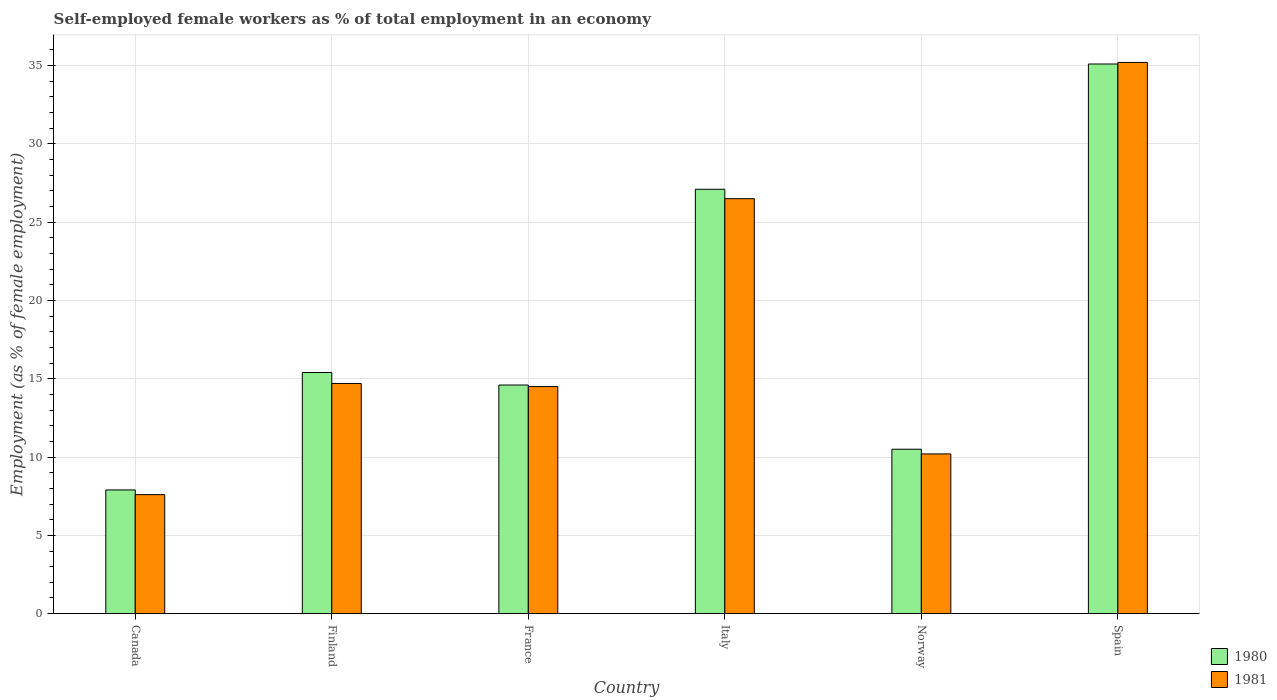How many different coloured bars are there?
Offer a terse response. 2. How many groups of bars are there?
Provide a short and direct response. 6. Are the number of bars per tick equal to the number of legend labels?
Keep it short and to the point. Yes. How many bars are there on the 5th tick from the left?
Make the answer very short. 2. What is the percentage of self-employed female workers in 1980 in Italy?
Provide a short and direct response. 27.1. Across all countries, what is the maximum percentage of self-employed female workers in 1980?
Your answer should be very brief. 35.1. Across all countries, what is the minimum percentage of self-employed female workers in 1980?
Your answer should be compact. 7.9. What is the total percentage of self-employed female workers in 1980 in the graph?
Offer a terse response. 110.6. What is the difference between the percentage of self-employed female workers in 1980 in Canada and that in Spain?
Make the answer very short. -27.2. What is the difference between the percentage of self-employed female workers in 1980 in Finland and the percentage of self-employed female workers in 1981 in Italy?
Your response must be concise. -11.1. What is the average percentage of self-employed female workers in 1981 per country?
Provide a short and direct response. 18.12. What is the difference between the percentage of self-employed female workers of/in 1981 and percentage of self-employed female workers of/in 1980 in Canada?
Keep it short and to the point. -0.3. What is the ratio of the percentage of self-employed female workers in 1981 in Finland to that in Italy?
Ensure brevity in your answer.  0.55. Is the percentage of self-employed female workers in 1980 in Finland less than that in Spain?
Give a very brief answer. Yes. What is the difference between the highest and the second highest percentage of self-employed female workers in 1981?
Provide a short and direct response. -8.7. What is the difference between the highest and the lowest percentage of self-employed female workers in 1981?
Keep it short and to the point. 27.6. In how many countries, is the percentage of self-employed female workers in 1981 greater than the average percentage of self-employed female workers in 1981 taken over all countries?
Make the answer very short. 2. What does the 2nd bar from the left in Spain represents?
Give a very brief answer. 1981. How many bars are there?
Ensure brevity in your answer.  12. Are all the bars in the graph horizontal?
Provide a succinct answer. No. What is the difference between two consecutive major ticks on the Y-axis?
Give a very brief answer. 5. Are the values on the major ticks of Y-axis written in scientific E-notation?
Give a very brief answer. No. Does the graph contain any zero values?
Give a very brief answer. No. How are the legend labels stacked?
Provide a succinct answer. Vertical. What is the title of the graph?
Your response must be concise. Self-employed female workers as % of total employment in an economy. What is the label or title of the Y-axis?
Make the answer very short. Employment (as % of female employment). What is the Employment (as % of female employment) in 1980 in Canada?
Make the answer very short. 7.9. What is the Employment (as % of female employment) of 1981 in Canada?
Make the answer very short. 7.6. What is the Employment (as % of female employment) in 1980 in Finland?
Provide a succinct answer. 15.4. What is the Employment (as % of female employment) of 1981 in Finland?
Provide a short and direct response. 14.7. What is the Employment (as % of female employment) in 1980 in France?
Give a very brief answer. 14.6. What is the Employment (as % of female employment) in 1981 in France?
Your answer should be compact. 14.5. What is the Employment (as % of female employment) in 1980 in Italy?
Your answer should be very brief. 27.1. What is the Employment (as % of female employment) of 1981 in Italy?
Provide a short and direct response. 26.5. What is the Employment (as % of female employment) in 1981 in Norway?
Ensure brevity in your answer.  10.2. What is the Employment (as % of female employment) in 1980 in Spain?
Make the answer very short. 35.1. What is the Employment (as % of female employment) in 1981 in Spain?
Your answer should be compact. 35.2. Across all countries, what is the maximum Employment (as % of female employment) in 1980?
Your answer should be compact. 35.1. Across all countries, what is the maximum Employment (as % of female employment) of 1981?
Your response must be concise. 35.2. Across all countries, what is the minimum Employment (as % of female employment) in 1980?
Give a very brief answer. 7.9. Across all countries, what is the minimum Employment (as % of female employment) of 1981?
Make the answer very short. 7.6. What is the total Employment (as % of female employment) in 1980 in the graph?
Give a very brief answer. 110.6. What is the total Employment (as % of female employment) in 1981 in the graph?
Ensure brevity in your answer.  108.7. What is the difference between the Employment (as % of female employment) of 1981 in Canada and that in Finland?
Your response must be concise. -7.1. What is the difference between the Employment (as % of female employment) of 1980 in Canada and that in France?
Provide a succinct answer. -6.7. What is the difference between the Employment (as % of female employment) in 1980 in Canada and that in Italy?
Offer a terse response. -19.2. What is the difference between the Employment (as % of female employment) in 1981 in Canada and that in Italy?
Your response must be concise. -18.9. What is the difference between the Employment (as % of female employment) of 1980 in Canada and that in Norway?
Make the answer very short. -2.6. What is the difference between the Employment (as % of female employment) in 1980 in Canada and that in Spain?
Keep it short and to the point. -27.2. What is the difference between the Employment (as % of female employment) in 1981 in Canada and that in Spain?
Keep it short and to the point. -27.6. What is the difference between the Employment (as % of female employment) in 1981 in Finland and that in France?
Your answer should be compact. 0.2. What is the difference between the Employment (as % of female employment) of 1980 in Finland and that in Italy?
Your answer should be very brief. -11.7. What is the difference between the Employment (as % of female employment) in 1980 in Finland and that in Spain?
Keep it short and to the point. -19.7. What is the difference between the Employment (as % of female employment) of 1981 in Finland and that in Spain?
Offer a terse response. -20.5. What is the difference between the Employment (as % of female employment) in 1981 in France and that in Norway?
Make the answer very short. 4.3. What is the difference between the Employment (as % of female employment) of 1980 in France and that in Spain?
Make the answer very short. -20.5. What is the difference between the Employment (as % of female employment) in 1981 in France and that in Spain?
Keep it short and to the point. -20.7. What is the difference between the Employment (as % of female employment) in 1980 in Norway and that in Spain?
Offer a terse response. -24.6. What is the difference between the Employment (as % of female employment) in 1980 in Canada and the Employment (as % of female employment) in 1981 in Italy?
Make the answer very short. -18.6. What is the difference between the Employment (as % of female employment) of 1980 in Canada and the Employment (as % of female employment) of 1981 in Spain?
Your answer should be very brief. -27.3. What is the difference between the Employment (as % of female employment) in 1980 in Finland and the Employment (as % of female employment) in 1981 in Italy?
Ensure brevity in your answer.  -11.1. What is the difference between the Employment (as % of female employment) in 1980 in Finland and the Employment (as % of female employment) in 1981 in Spain?
Your answer should be very brief. -19.8. What is the difference between the Employment (as % of female employment) of 1980 in France and the Employment (as % of female employment) of 1981 in Norway?
Make the answer very short. 4.4. What is the difference between the Employment (as % of female employment) of 1980 in France and the Employment (as % of female employment) of 1981 in Spain?
Offer a very short reply. -20.6. What is the difference between the Employment (as % of female employment) in 1980 in Norway and the Employment (as % of female employment) in 1981 in Spain?
Your answer should be compact. -24.7. What is the average Employment (as % of female employment) of 1980 per country?
Ensure brevity in your answer.  18.43. What is the average Employment (as % of female employment) in 1981 per country?
Ensure brevity in your answer.  18.12. What is the difference between the Employment (as % of female employment) of 1980 and Employment (as % of female employment) of 1981 in Italy?
Your response must be concise. 0.6. What is the ratio of the Employment (as % of female employment) in 1980 in Canada to that in Finland?
Offer a very short reply. 0.51. What is the ratio of the Employment (as % of female employment) in 1981 in Canada to that in Finland?
Your response must be concise. 0.52. What is the ratio of the Employment (as % of female employment) of 1980 in Canada to that in France?
Your response must be concise. 0.54. What is the ratio of the Employment (as % of female employment) in 1981 in Canada to that in France?
Give a very brief answer. 0.52. What is the ratio of the Employment (as % of female employment) of 1980 in Canada to that in Italy?
Your answer should be very brief. 0.29. What is the ratio of the Employment (as % of female employment) of 1981 in Canada to that in Italy?
Your answer should be very brief. 0.29. What is the ratio of the Employment (as % of female employment) in 1980 in Canada to that in Norway?
Give a very brief answer. 0.75. What is the ratio of the Employment (as % of female employment) of 1981 in Canada to that in Norway?
Offer a terse response. 0.75. What is the ratio of the Employment (as % of female employment) in 1980 in Canada to that in Spain?
Offer a terse response. 0.23. What is the ratio of the Employment (as % of female employment) in 1981 in Canada to that in Spain?
Offer a terse response. 0.22. What is the ratio of the Employment (as % of female employment) of 1980 in Finland to that in France?
Your answer should be compact. 1.05. What is the ratio of the Employment (as % of female employment) of 1981 in Finland to that in France?
Keep it short and to the point. 1.01. What is the ratio of the Employment (as % of female employment) of 1980 in Finland to that in Italy?
Your answer should be compact. 0.57. What is the ratio of the Employment (as % of female employment) of 1981 in Finland to that in Italy?
Offer a very short reply. 0.55. What is the ratio of the Employment (as % of female employment) in 1980 in Finland to that in Norway?
Provide a succinct answer. 1.47. What is the ratio of the Employment (as % of female employment) of 1981 in Finland to that in Norway?
Provide a short and direct response. 1.44. What is the ratio of the Employment (as % of female employment) in 1980 in Finland to that in Spain?
Your answer should be compact. 0.44. What is the ratio of the Employment (as % of female employment) of 1981 in Finland to that in Spain?
Offer a very short reply. 0.42. What is the ratio of the Employment (as % of female employment) of 1980 in France to that in Italy?
Your answer should be very brief. 0.54. What is the ratio of the Employment (as % of female employment) of 1981 in France to that in Italy?
Provide a succinct answer. 0.55. What is the ratio of the Employment (as % of female employment) in 1980 in France to that in Norway?
Offer a terse response. 1.39. What is the ratio of the Employment (as % of female employment) in 1981 in France to that in Norway?
Make the answer very short. 1.42. What is the ratio of the Employment (as % of female employment) in 1980 in France to that in Spain?
Offer a terse response. 0.42. What is the ratio of the Employment (as % of female employment) of 1981 in France to that in Spain?
Provide a short and direct response. 0.41. What is the ratio of the Employment (as % of female employment) in 1980 in Italy to that in Norway?
Ensure brevity in your answer.  2.58. What is the ratio of the Employment (as % of female employment) in 1981 in Italy to that in Norway?
Your answer should be compact. 2.6. What is the ratio of the Employment (as % of female employment) in 1980 in Italy to that in Spain?
Offer a very short reply. 0.77. What is the ratio of the Employment (as % of female employment) in 1981 in Italy to that in Spain?
Give a very brief answer. 0.75. What is the ratio of the Employment (as % of female employment) in 1980 in Norway to that in Spain?
Your answer should be very brief. 0.3. What is the ratio of the Employment (as % of female employment) of 1981 in Norway to that in Spain?
Your response must be concise. 0.29. What is the difference between the highest and the second highest Employment (as % of female employment) of 1980?
Offer a very short reply. 8. What is the difference between the highest and the lowest Employment (as % of female employment) in 1980?
Make the answer very short. 27.2. What is the difference between the highest and the lowest Employment (as % of female employment) in 1981?
Ensure brevity in your answer.  27.6. 